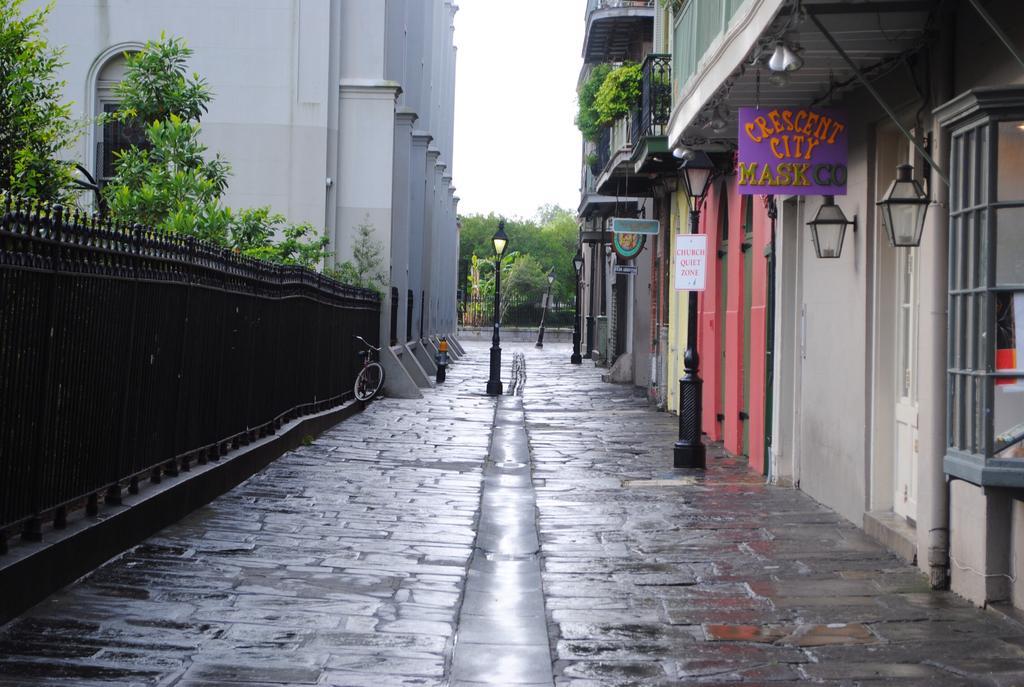Can you describe this image briefly? This image consists of a road. On the left and right, there are buildings. On the left, there are plants. At the top, there is sky. In the background, there are many trees. And we can see the lambs to the poles and walls. 